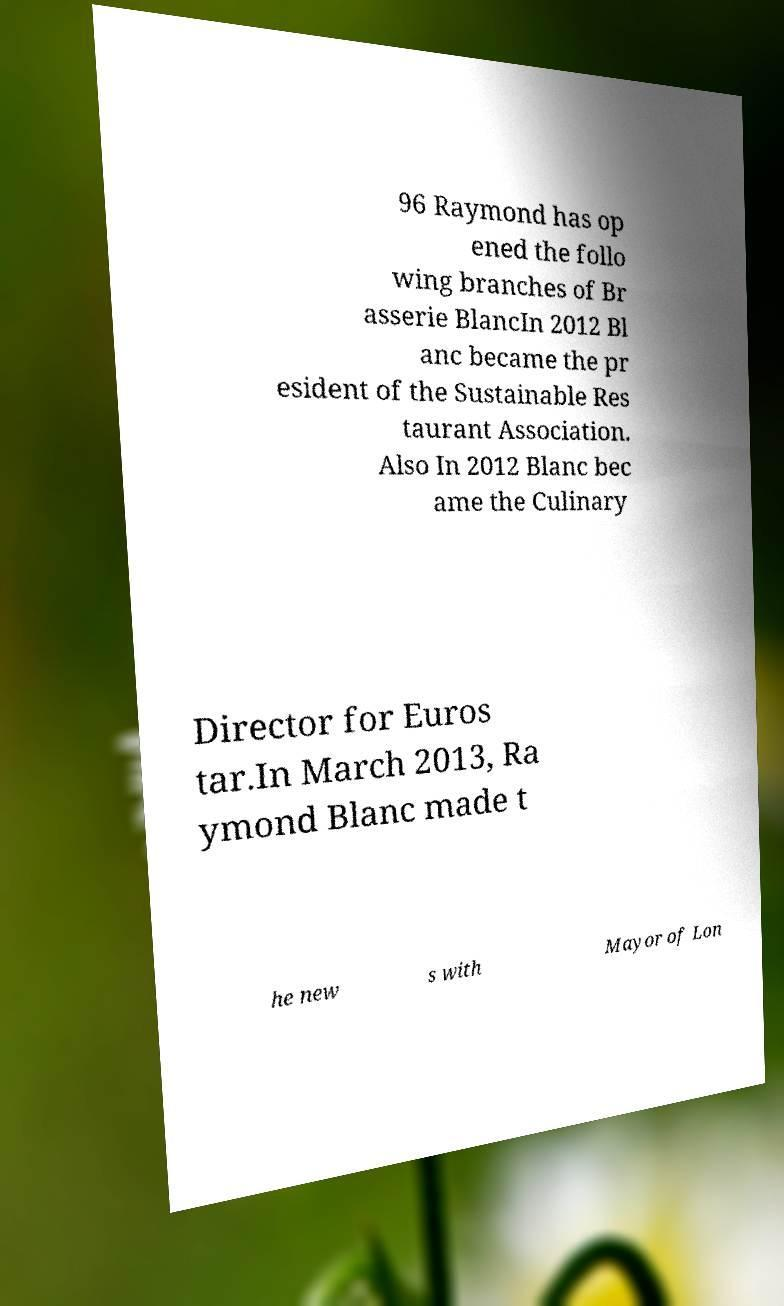Please read and relay the text visible in this image. What does it say? 96 Raymond has op ened the follo wing branches of Br asserie BlancIn 2012 Bl anc became the pr esident of the Sustainable Res taurant Association. Also In 2012 Blanc bec ame the Culinary Director for Euros tar.In March 2013, Ra ymond Blanc made t he new s with Mayor of Lon 